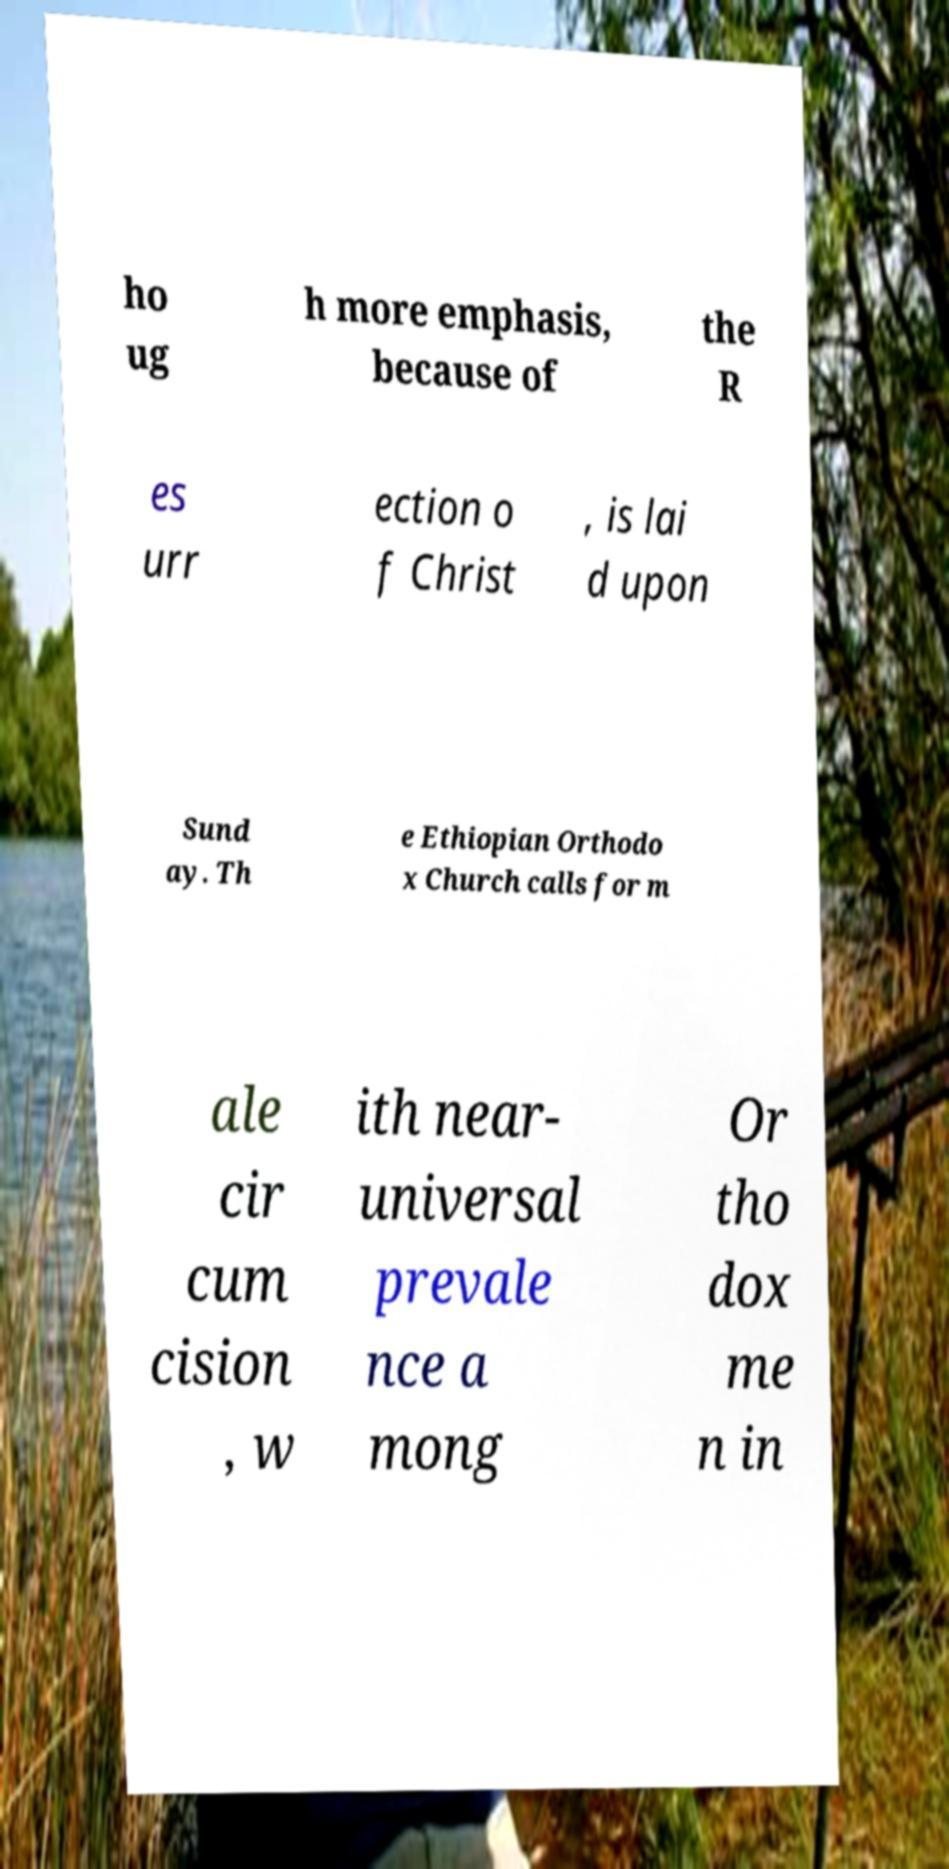Can you accurately transcribe the text from the provided image for me? ho ug h more emphasis, because of the R es urr ection o f Christ , is lai d upon Sund ay. Th e Ethiopian Orthodo x Church calls for m ale cir cum cision , w ith near- universal prevale nce a mong Or tho dox me n in 